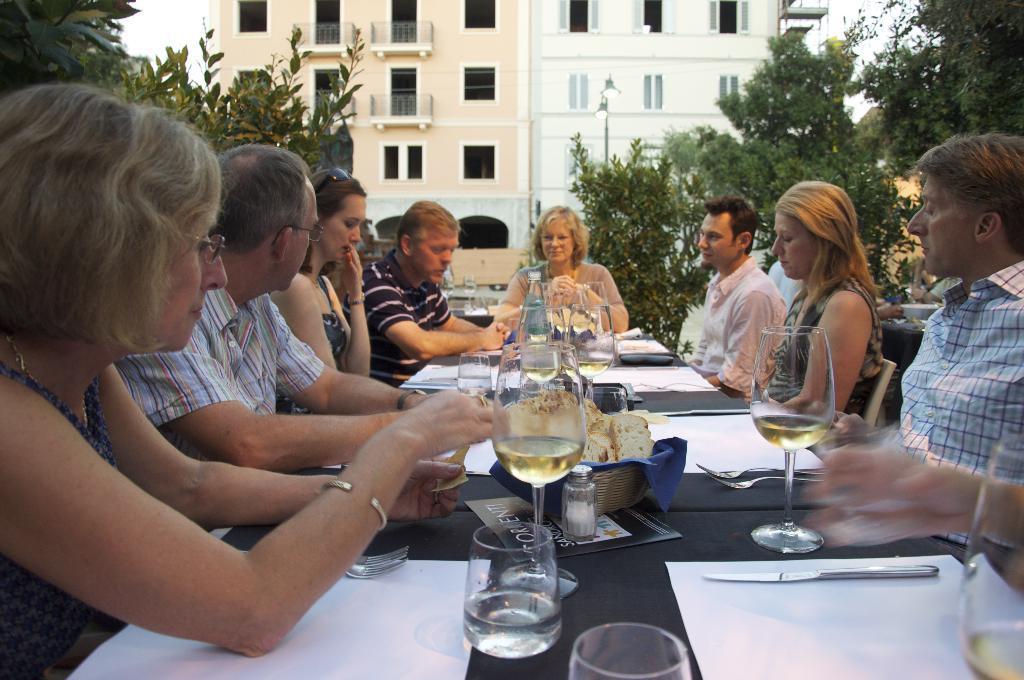In one or two sentences, can you explain what this image depicts? In this image, we can see group of people are sat on the chair. In the middle, there is a black color table. Few items are placed on it. On the right side and left side, we can see so many trees. And background, we can see a building. 